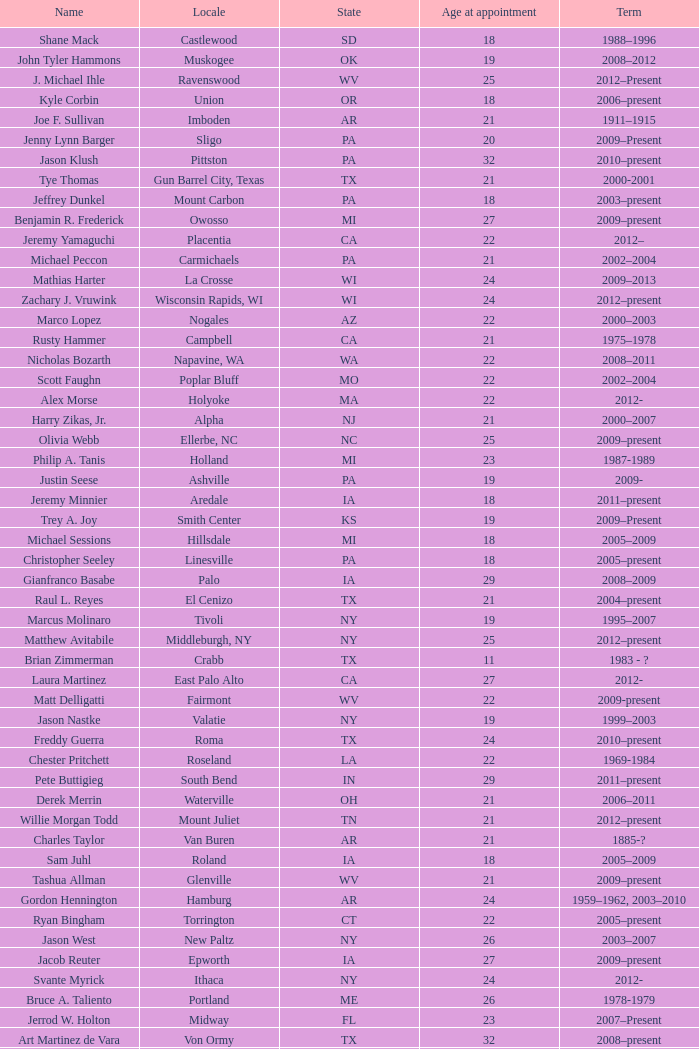What is the name of the holland locale Philip A. Tanis. 